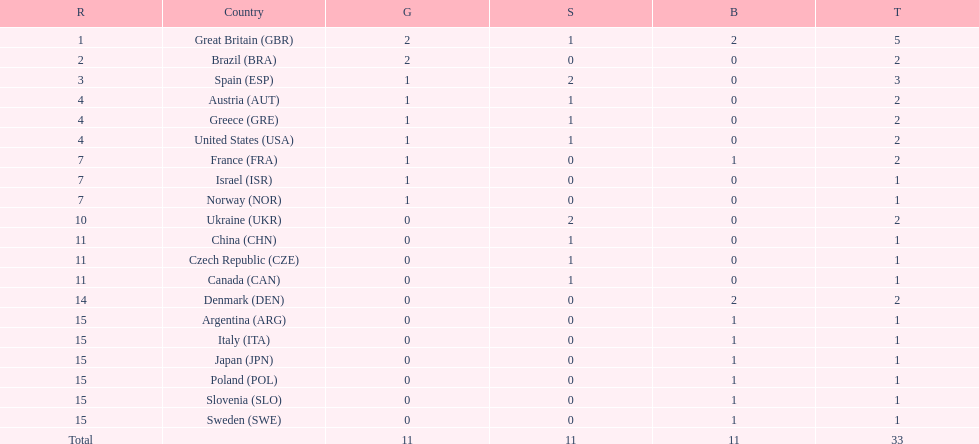How many countries won at least 2 medals in sailing? 9. 